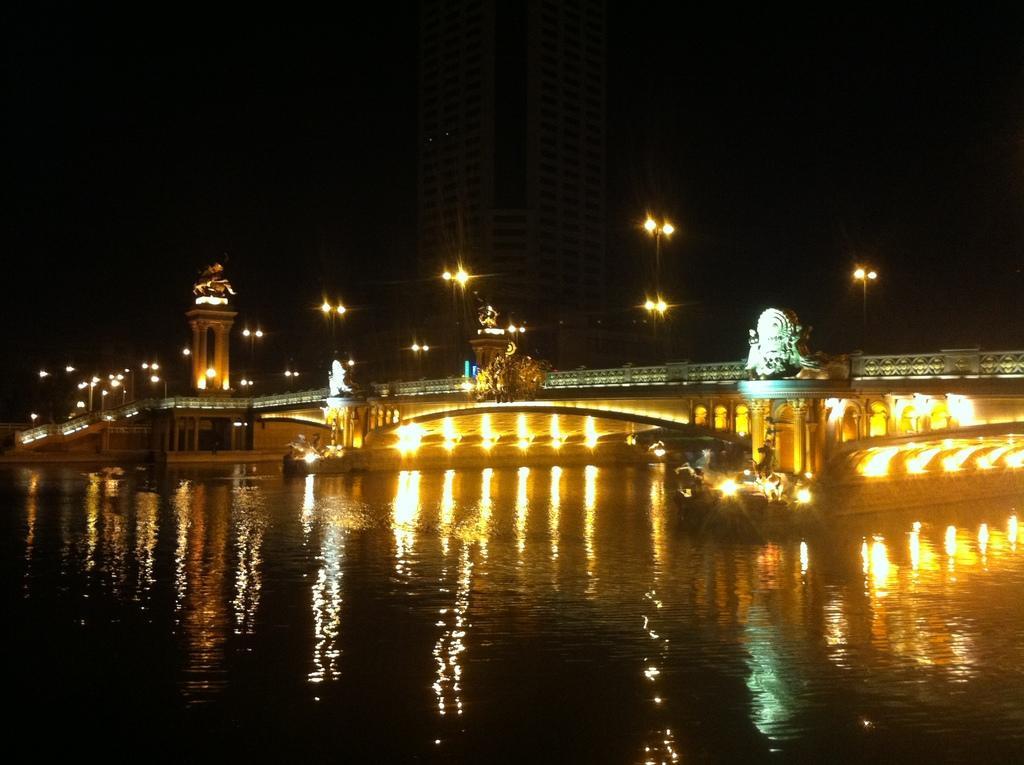Could you give a brief overview of what you see in this image? In this image we can see a bridge. There is a lake in the image. There is a sky in the image. There are many lights in the image. There is a reflection of lights and a bridge on the water surface in the image. 